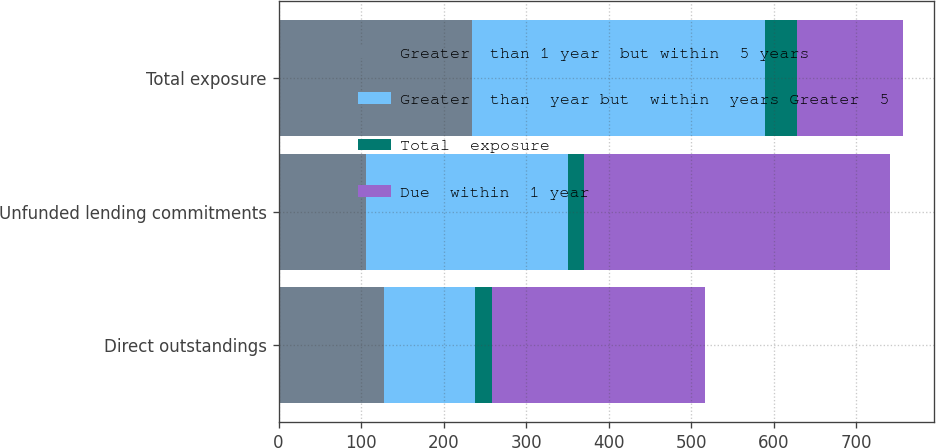Convert chart. <chart><loc_0><loc_0><loc_500><loc_500><stacked_bar_chart><ecel><fcel>Direct outstandings<fcel>Unfunded lending commitments<fcel>Total exposure<nl><fcel>Greater  than 1 year  but within  5 years<fcel>128<fcel>106<fcel>234<nl><fcel>Greater  than  year but  within  years Greater  5<fcel>110<fcel>245<fcel>355<nl><fcel>Total  exposure<fcel>20<fcel>19<fcel>39<nl><fcel>Due  within  1 year<fcel>258<fcel>370<fcel>128<nl></chart> 